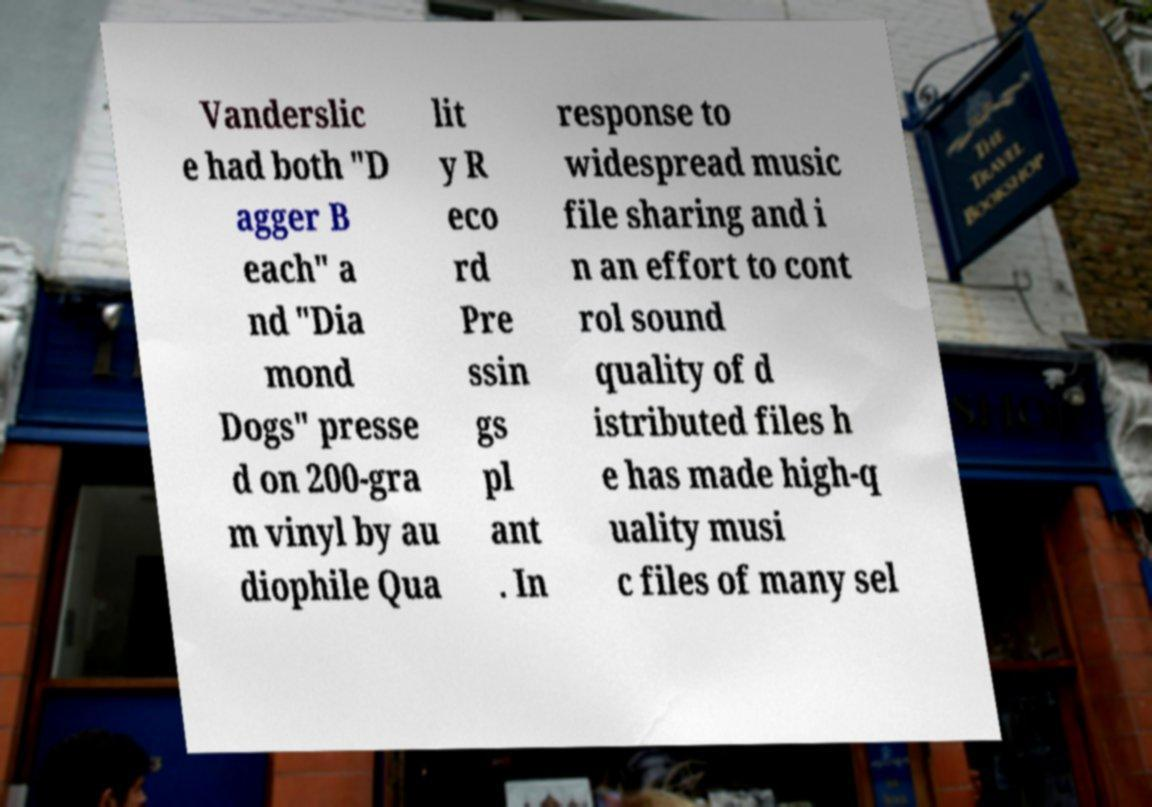Please read and relay the text visible in this image. What does it say? Vanderslic e had both "D agger B each" a nd "Dia mond Dogs" presse d on 200-gra m vinyl by au diophile Qua lit y R eco rd Pre ssin gs pl ant . In response to widespread music file sharing and i n an effort to cont rol sound quality of d istributed files h e has made high-q uality musi c files of many sel 